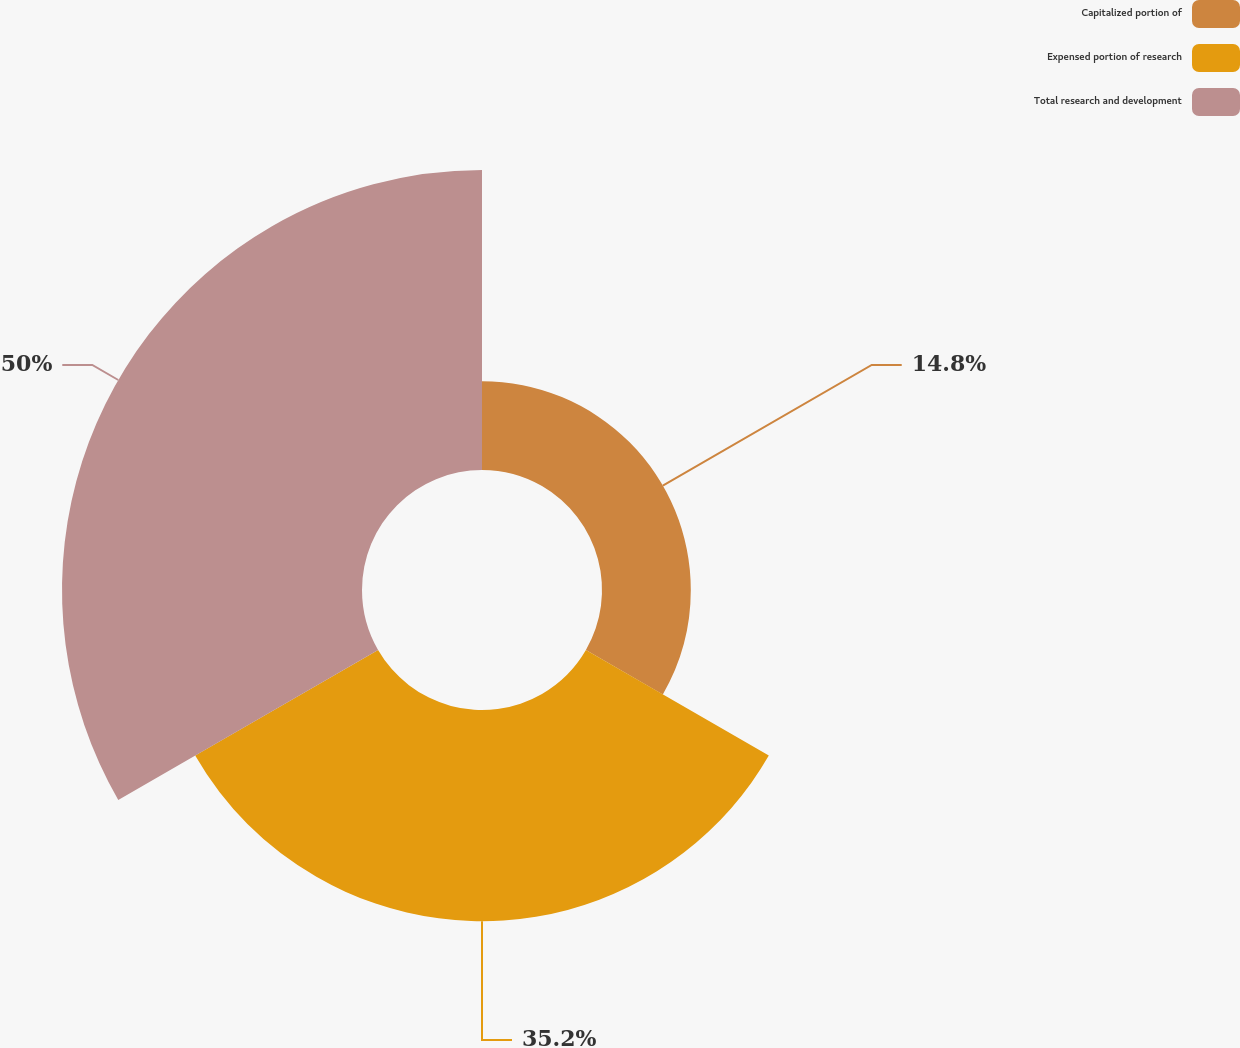<chart> <loc_0><loc_0><loc_500><loc_500><pie_chart><fcel>Capitalized portion of<fcel>Expensed portion of research<fcel>Total research and development<nl><fcel>14.8%<fcel>35.2%<fcel>50.0%<nl></chart> 